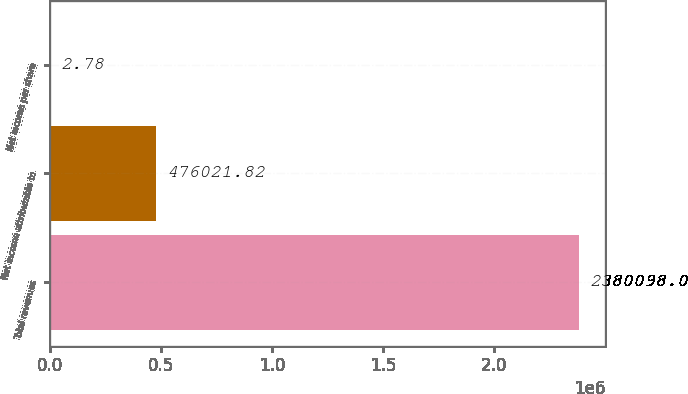Convert chart. <chart><loc_0><loc_0><loc_500><loc_500><bar_chart><fcel>Total revenues<fcel>Net income attributable to<fcel>Net income per share<nl><fcel>2.3801e+06<fcel>476022<fcel>2.78<nl></chart> 